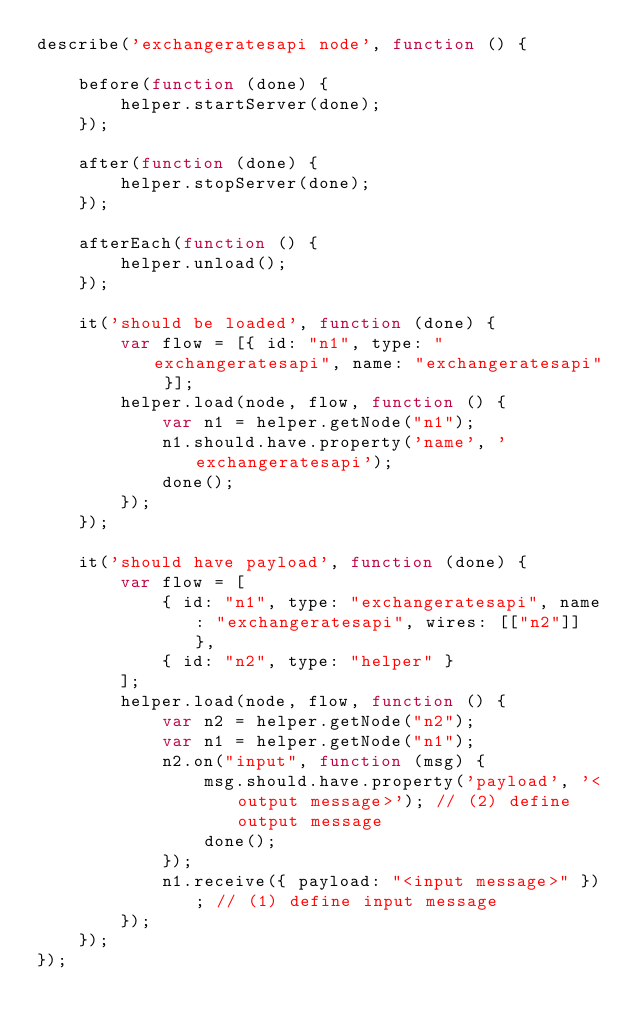<code> <loc_0><loc_0><loc_500><loc_500><_JavaScript_>describe('exchangeratesapi node', function () {

    before(function (done) {
        helper.startServer(done);
    });

    after(function (done) {
        helper.stopServer(done);
    });

    afterEach(function () {
        helper.unload();
    });

    it('should be loaded', function (done) {
        var flow = [{ id: "n1", type: "exchangeratesapi", name: "exchangeratesapi" }];
        helper.load(node, flow, function () {
            var n1 = helper.getNode("n1");
            n1.should.have.property('name', 'exchangeratesapi');
            done();
        });
    });

    it('should have payload', function (done) {
        var flow = [
            { id: "n1", type: "exchangeratesapi", name: "exchangeratesapi", wires: [["n2"]] },
            { id: "n2", type: "helper" }
        ];
        helper.load(node, flow, function () {
            var n2 = helper.getNode("n2");
            var n1 = helper.getNode("n1");
            n2.on("input", function (msg) {
                msg.should.have.property('payload', '<output message>'); // (2) define output message
                done();
            });
            n1.receive({ payload: "<input message>" }); // (1) define input message
        });
    });
});

</code> 